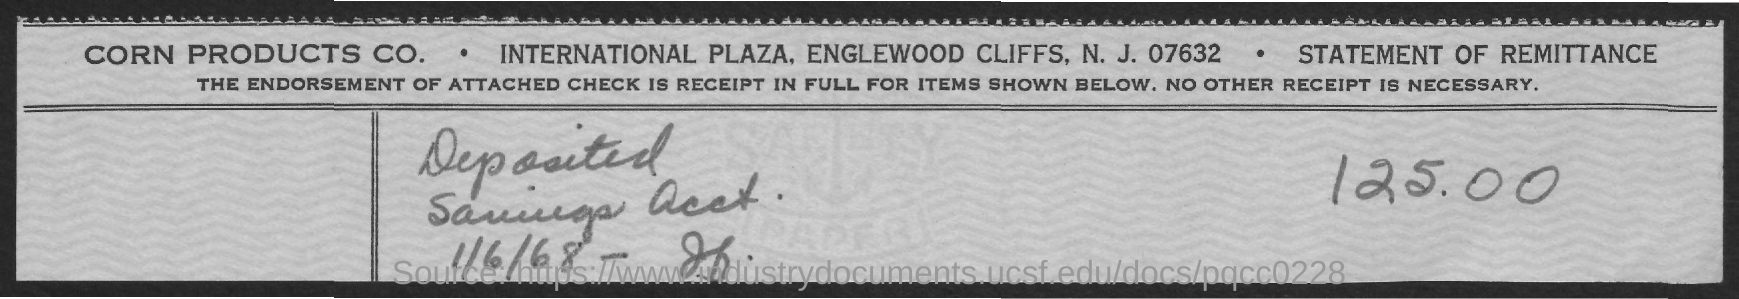What is the amount deposited as per the statement?
Your answer should be compact. 125.00. What is the deposit date mentioned in the statement?
Give a very brief answer. 1/6/68. What type of statement is given here?
Provide a succinct answer. Remittance. 